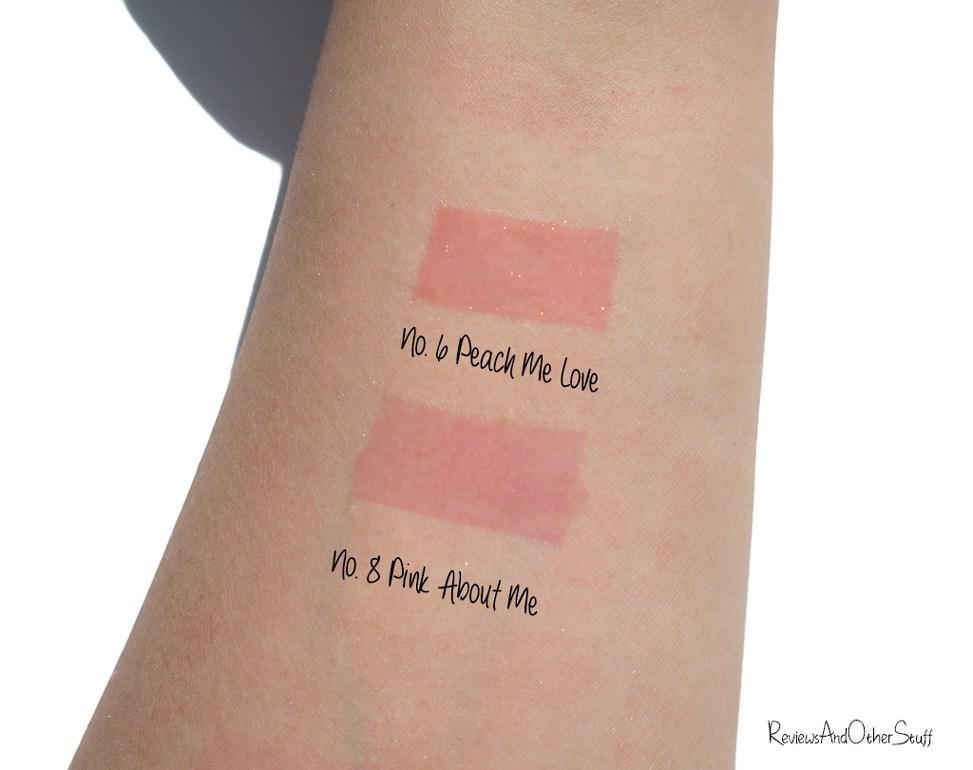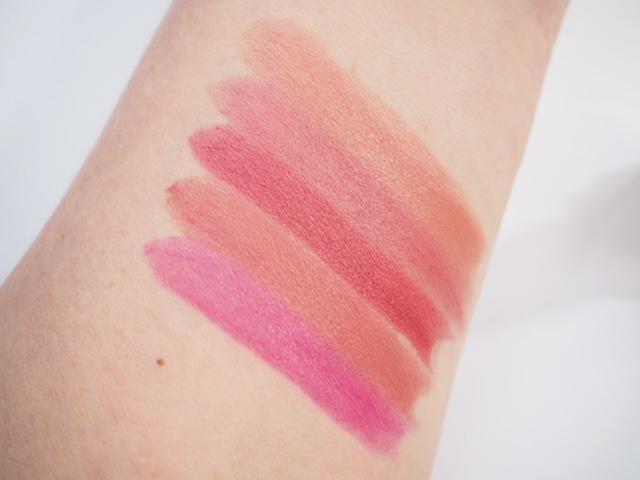The first image is the image on the left, the second image is the image on the right. Examine the images to the left and right. Is the description "The right image contains a human arm with several different shades of lipstick drawn on it." accurate? Answer yes or no. Yes. The first image is the image on the left, the second image is the image on the right. Assess this claim about the two images: "One image features a row of five uncapped tube lipsticks, and the other image shows an inner arm with five lipstick marks.". Correct or not? Answer yes or no. No. 